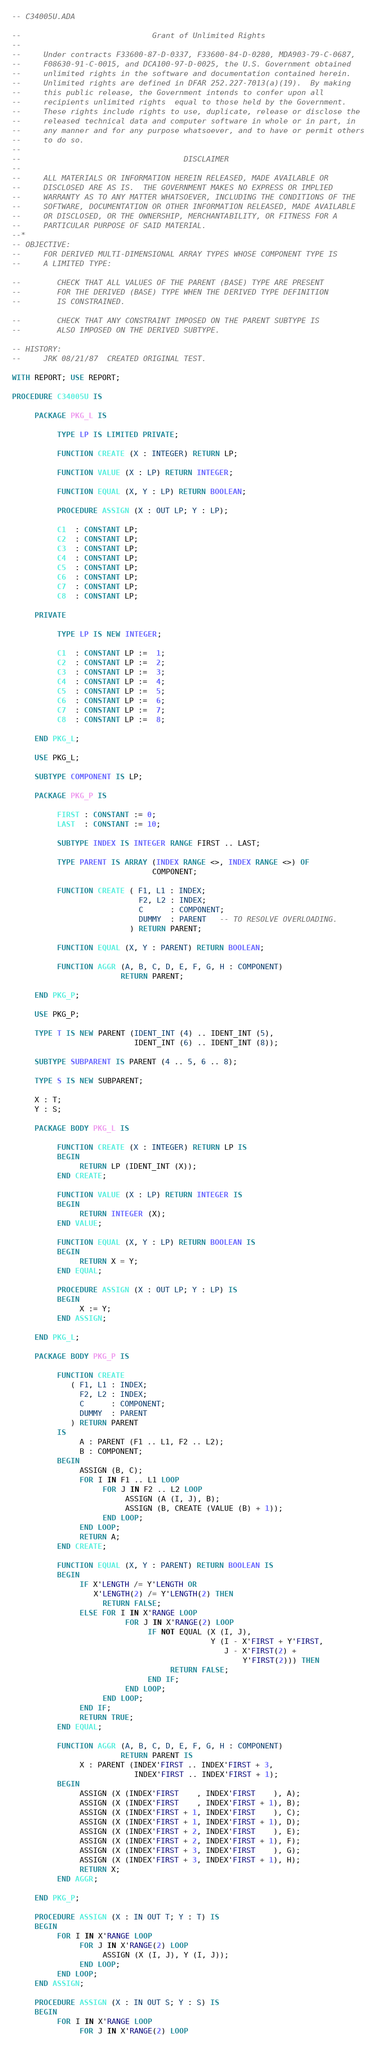Convert code to text. <code><loc_0><loc_0><loc_500><loc_500><_Ada_>-- C34005U.ADA

--                             Grant of Unlimited Rights
--
--     Under contracts F33600-87-D-0337, F33600-84-D-0280, MDA903-79-C-0687,
--     F08630-91-C-0015, and DCA100-97-D-0025, the U.S. Government obtained 
--     unlimited rights in the software and documentation contained herein.
--     Unlimited rights are defined in DFAR 252.227-7013(a)(19).  By making 
--     this public release, the Government intends to confer upon all 
--     recipients unlimited rights  equal to those held by the Government.  
--     These rights include rights to use, duplicate, release or disclose the 
--     released technical data and computer software in whole or in part, in 
--     any manner and for any purpose whatsoever, and to have or permit others 
--     to do so.
--
--                                    DISCLAIMER
--
--     ALL MATERIALS OR INFORMATION HEREIN RELEASED, MADE AVAILABLE OR
--     DISCLOSED ARE AS IS.  THE GOVERNMENT MAKES NO EXPRESS OR IMPLIED 
--     WARRANTY AS TO ANY MATTER WHATSOEVER, INCLUDING THE CONDITIONS OF THE
--     SOFTWARE, DOCUMENTATION OR OTHER INFORMATION RELEASED, MADE AVAILABLE 
--     OR DISCLOSED, OR THE OWNERSHIP, MERCHANTABILITY, OR FITNESS FOR A
--     PARTICULAR PURPOSE OF SAID MATERIAL.
--*
-- OBJECTIVE:
--     FOR DERIVED MULTI-DIMENSIONAL ARRAY TYPES WHOSE COMPONENT TYPE IS
--     A LIMITED TYPE:

--        CHECK THAT ALL VALUES OF THE PARENT (BASE) TYPE ARE PRESENT
--        FOR THE DERIVED (BASE) TYPE WHEN THE DERIVED TYPE DEFINITION
--        IS CONSTRAINED.

--        CHECK THAT ANY CONSTRAINT IMPOSED ON THE PARENT SUBTYPE IS
--        ALSO IMPOSED ON THE DERIVED SUBTYPE.

-- HISTORY:
--     JRK 08/21/87  CREATED ORIGINAL TEST.

WITH REPORT; USE REPORT;

PROCEDURE C34005U IS

     PACKAGE PKG_L IS

          TYPE LP IS LIMITED PRIVATE;

          FUNCTION CREATE (X : INTEGER) RETURN LP;

          FUNCTION VALUE (X : LP) RETURN INTEGER;

          FUNCTION EQUAL (X, Y : LP) RETURN BOOLEAN;

          PROCEDURE ASSIGN (X : OUT LP; Y : LP);

          C1  : CONSTANT LP;
          C2  : CONSTANT LP;
          C3  : CONSTANT LP;
          C4  : CONSTANT LP;
          C5  : CONSTANT LP;
          C6  : CONSTANT LP;
          C7  : CONSTANT LP;
          C8  : CONSTANT LP;

     PRIVATE

          TYPE LP IS NEW INTEGER;

          C1  : CONSTANT LP :=  1;
          C2  : CONSTANT LP :=  2;
          C3  : CONSTANT LP :=  3;
          C4  : CONSTANT LP :=  4;
          C5  : CONSTANT LP :=  5;
          C6  : CONSTANT LP :=  6;
          C7  : CONSTANT LP :=  7;
          C8  : CONSTANT LP :=  8;

     END PKG_L;

     USE PKG_L;

     SUBTYPE COMPONENT IS LP;

     PACKAGE PKG_P IS

          FIRST : CONSTANT := 0;
          LAST  : CONSTANT := 10;

          SUBTYPE INDEX IS INTEGER RANGE FIRST .. LAST;

          TYPE PARENT IS ARRAY (INDEX RANGE <>, INDEX RANGE <>) OF
                               COMPONENT;

          FUNCTION CREATE ( F1, L1 : INDEX;
                            F2, L2 : INDEX;
                            C      : COMPONENT;
                            DUMMY  : PARENT   -- TO RESOLVE OVERLOADING.
                          ) RETURN PARENT;

          FUNCTION EQUAL (X, Y : PARENT) RETURN BOOLEAN;

          FUNCTION AGGR (A, B, C, D, E, F, G, H : COMPONENT)
                        RETURN PARENT;

     END PKG_P;

     USE PKG_P;

     TYPE T IS NEW PARENT (IDENT_INT (4) .. IDENT_INT (5),
                           IDENT_INT (6) .. IDENT_INT (8));

     SUBTYPE SUBPARENT IS PARENT (4 .. 5, 6 .. 8);

     TYPE S IS NEW SUBPARENT;

     X : T;
     Y : S;

     PACKAGE BODY PKG_L IS

          FUNCTION CREATE (X : INTEGER) RETURN LP IS
          BEGIN
               RETURN LP (IDENT_INT (X));
          END CREATE;

          FUNCTION VALUE (X : LP) RETURN INTEGER IS
          BEGIN
               RETURN INTEGER (X);
          END VALUE;

          FUNCTION EQUAL (X, Y : LP) RETURN BOOLEAN IS
          BEGIN
               RETURN X = Y;
          END EQUAL;

          PROCEDURE ASSIGN (X : OUT LP; Y : LP) IS
          BEGIN
               X := Y;
          END ASSIGN;

     END PKG_L;

     PACKAGE BODY PKG_P IS

          FUNCTION CREATE
             ( F1, L1 : INDEX;
               F2, L2 : INDEX;
               C      : COMPONENT;
               DUMMY  : PARENT
             ) RETURN PARENT
          IS
               A : PARENT (F1 .. L1, F2 .. L2);
               B : COMPONENT;
          BEGIN
               ASSIGN (B, C);
               FOR I IN F1 .. L1 LOOP
                    FOR J IN F2 .. L2 LOOP
                         ASSIGN (A (I, J), B);
                         ASSIGN (B, CREATE (VALUE (B) + 1));
                    END LOOP;
               END LOOP;
               RETURN A;
          END CREATE;

          FUNCTION EQUAL (X, Y : PARENT) RETURN BOOLEAN IS
          BEGIN
               IF X'LENGTH /= Y'LENGTH OR
                  X'LENGTH(2) /= Y'LENGTH(2) THEN
                    RETURN FALSE;
               ELSE FOR I IN X'RANGE LOOP
                         FOR J IN X'RANGE(2) LOOP
                              IF NOT EQUAL (X (I, J),
                                            Y (I - X'FIRST + Y'FIRST,
                                               J - X'FIRST(2) +
                                                   Y'FIRST(2))) THEN
                                   RETURN FALSE;
                              END IF;
                         END LOOP;
                    END LOOP;
               END IF;
               RETURN TRUE;
          END EQUAL;

          FUNCTION AGGR (A, B, C, D, E, F, G, H : COMPONENT)
                        RETURN PARENT IS
               X : PARENT (INDEX'FIRST .. INDEX'FIRST + 3,
                           INDEX'FIRST .. INDEX'FIRST + 1);
          BEGIN
               ASSIGN (X (INDEX'FIRST    , INDEX'FIRST    ), A);
               ASSIGN (X (INDEX'FIRST    , INDEX'FIRST + 1), B);
               ASSIGN (X (INDEX'FIRST + 1, INDEX'FIRST    ), C);
               ASSIGN (X (INDEX'FIRST + 1, INDEX'FIRST + 1), D);
               ASSIGN (X (INDEX'FIRST + 2, INDEX'FIRST    ), E);
               ASSIGN (X (INDEX'FIRST + 2, INDEX'FIRST + 1), F);
               ASSIGN (X (INDEX'FIRST + 3, INDEX'FIRST    ), G);
               ASSIGN (X (INDEX'FIRST + 3, INDEX'FIRST + 1), H);
               RETURN X;
          END AGGR;

     END PKG_P;

     PROCEDURE ASSIGN (X : IN OUT T; Y : T) IS
     BEGIN
          FOR I IN X'RANGE LOOP
               FOR J IN X'RANGE(2) LOOP
                    ASSIGN (X (I, J), Y (I, J));
               END LOOP;
          END LOOP;
     END ASSIGN;

     PROCEDURE ASSIGN (X : IN OUT S; Y : S) IS
     BEGIN
          FOR I IN X'RANGE LOOP
               FOR J IN X'RANGE(2) LOOP</code> 